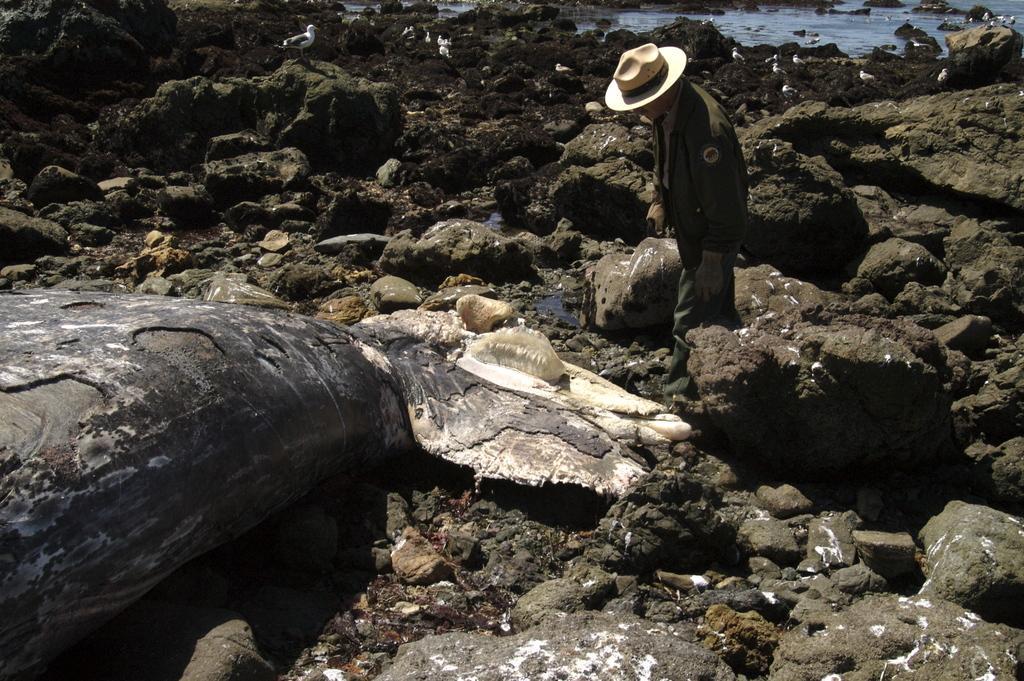Please provide a concise description of this image. In this image we can see a person wearing a cap and standing and we can also see mud stones. 